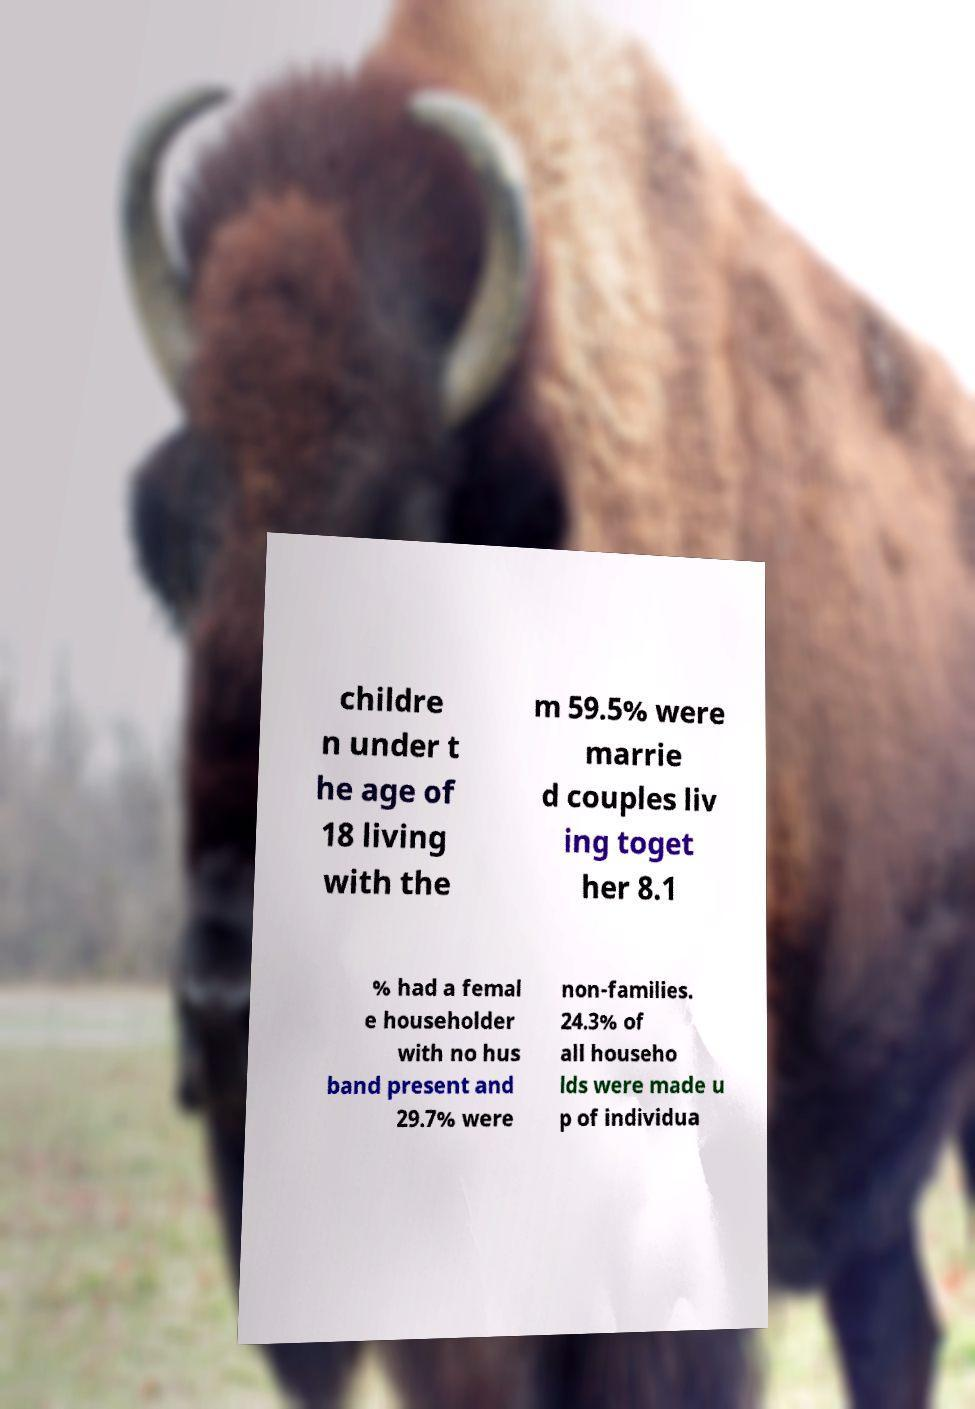Can you accurately transcribe the text from the provided image for me? childre n under t he age of 18 living with the m 59.5% were marrie d couples liv ing toget her 8.1 % had a femal e householder with no hus band present and 29.7% were non-families. 24.3% of all househo lds were made u p of individua 